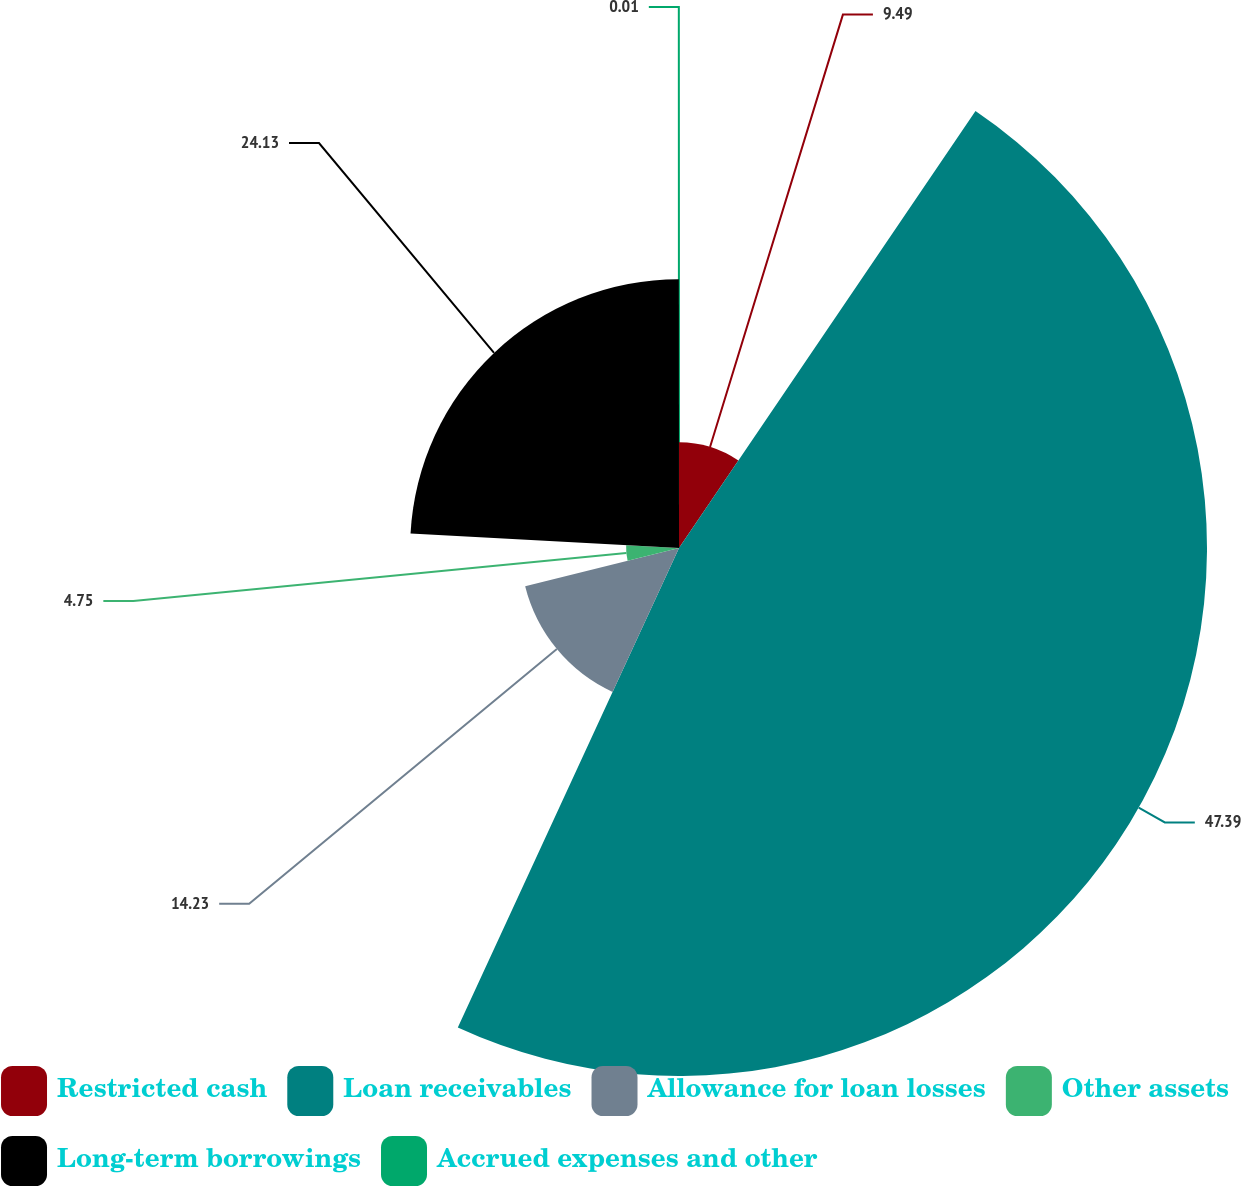Convert chart to OTSL. <chart><loc_0><loc_0><loc_500><loc_500><pie_chart><fcel>Restricted cash<fcel>Loan receivables<fcel>Allowance for loan losses<fcel>Other assets<fcel>Long-term borrowings<fcel>Accrued expenses and other<nl><fcel>9.49%<fcel>47.39%<fcel>14.23%<fcel>4.75%<fcel>24.13%<fcel>0.01%<nl></chart> 